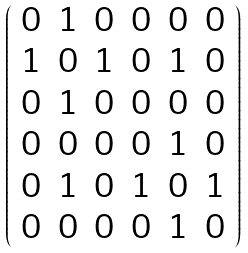<formula> <loc_0><loc_0><loc_500><loc_500>\left ( \begin{array} { c c c c c c } 0 & 1 & 0 & 0 & 0 & 0 \\ 1 & 0 & 1 & 0 & 1 & 0 \\ 0 & 1 & 0 & 0 & 0 & 0 \\ 0 & 0 & 0 & 0 & 1 & 0 \\ 0 & 1 & 0 & 1 & 0 & 1 \\ 0 & 0 & 0 & 0 & 1 & 0 \end{array} \right )</formula> 